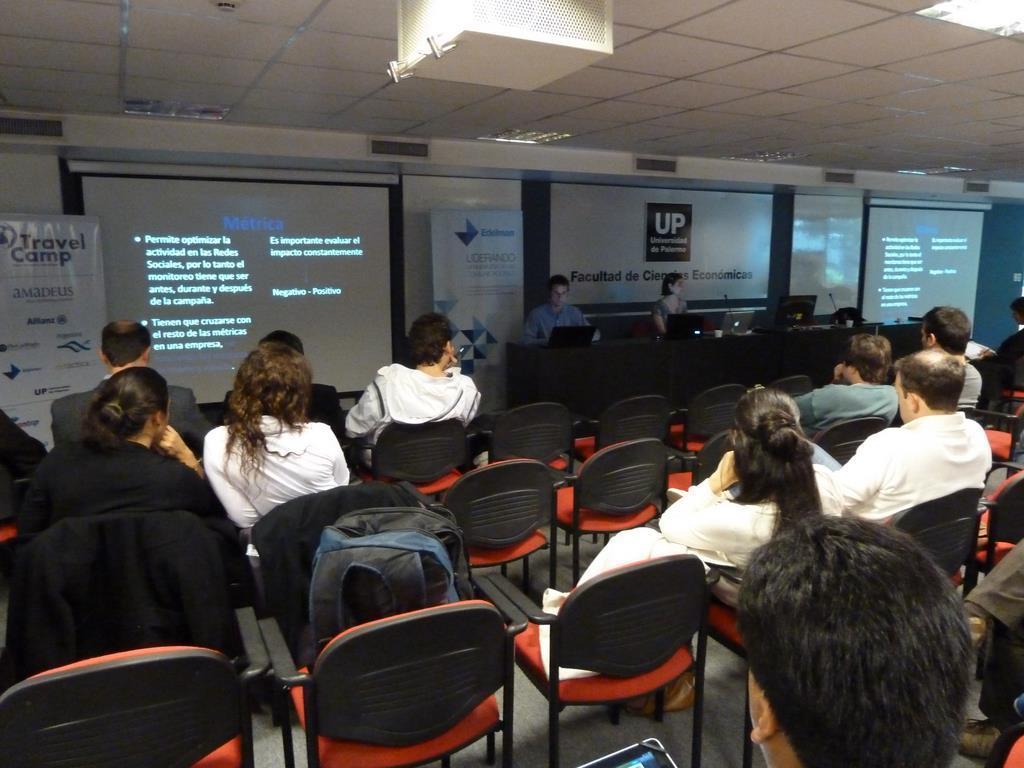Please provide a concise description of this image. In this image, there are group of people sitting on the chair in front of the screen. A roof top is white in color. In the left, there is a board written as travel camp. The walls are blue in color. In the middle, there are two persons sitting in front of the laptop on the chair at table and having a mike in front of them. this image is taken inside a hall. 